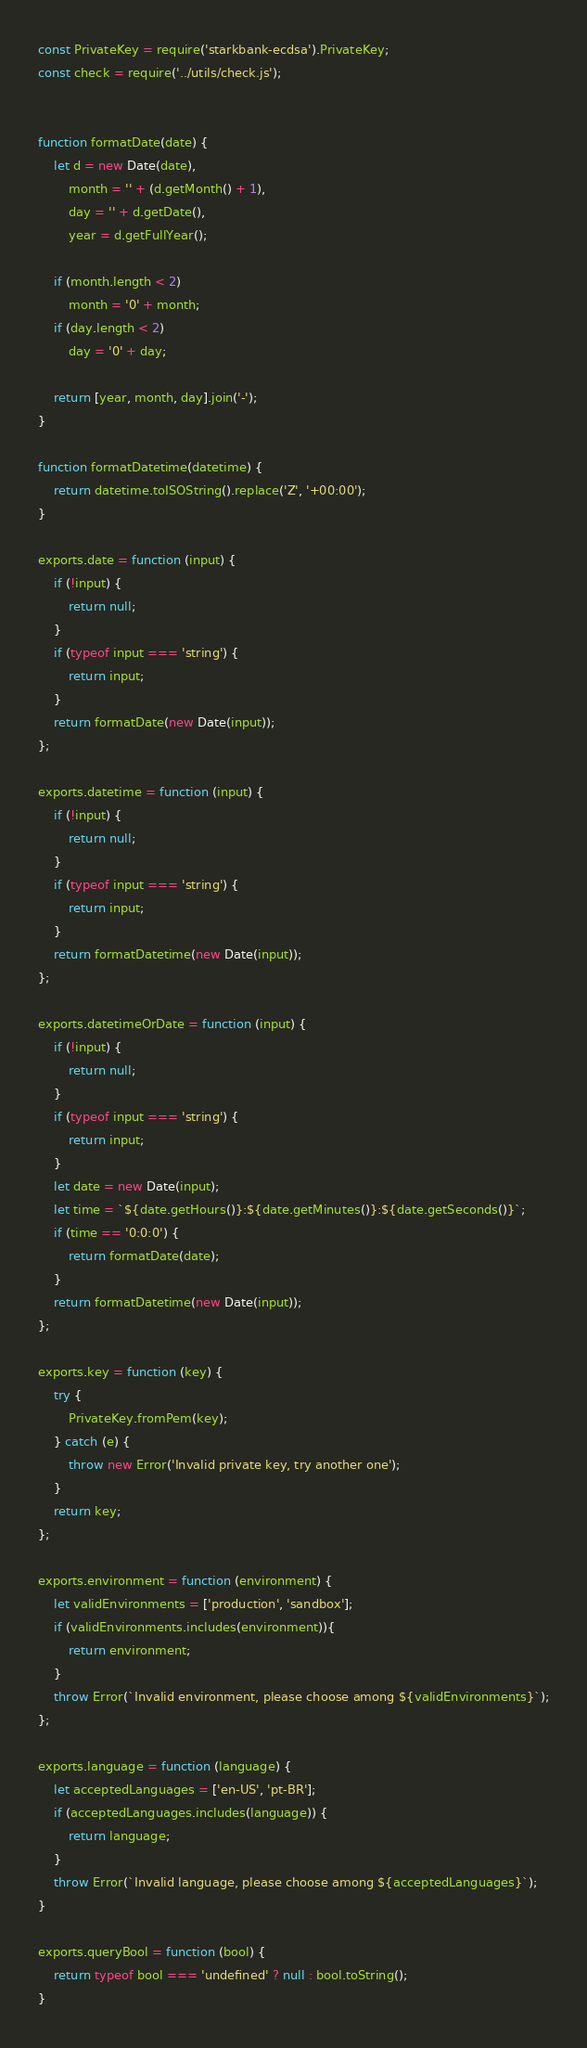Convert code to text. <code><loc_0><loc_0><loc_500><loc_500><_JavaScript_>const PrivateKey = require('starkbank-ecdsa').PrivateKey;
const check = require('../utils/check.js');


function formatDate(date) {
    let d = new Date(date),
        month = '' + (d.getMonth() + 1),
        day = '' + d.getDate(),
        year = d.getFullYear();

    if (month.length < 2)
        month = '0' + month;
    if (day.length < 2)
        day = '0' + day;

    return [year, month, day].join('-');
}

function formatDatetime(datetime) {
    return datetime.toISOString().replace('Z', '+00:00');
}

exports.date = function (input) {
    if (!input) {
        return null;
    }
    if (typeof input === 'string') {
        return input;
    }
    return formatDate(new Date(input));
};

exports.datetime = function (input) {
    if (!input) {
        return null;
    }
    if (typeof input === 'string') {
        return input;
    }
    return formatDatetime(new Date(input));
};

exports.datetimeOrDate = function (input) {
    if (!input) {
        return null;
    }
    if (typeof input === 'string') {
        return input;
    }
    let date = new Date(input);
    let time = `${date.getHours()}:${date.getMinutes()}:${date.getSeconds()}`;
    if (time == '0:0:0') {
        return formatDate(date);
    }
    return formatDatetime(new Date(input));
};

exports.key = function (key) {
    try {
        PrivateKey.fromPem(key);
    } catch (e) {
        throw new Error('Invalid private key, try another one');
    }
    return key;
};

exports.environment = function (environment) {
    let validEnvironments = ['production', 'sandbox'];
    if (validEnvironments.includes(environment)){
        return environment;
    }
    throw Error(`Invalid environment, please choose among ${validEnvironments}`);
};

exports.language = function (language) {
    let acceptedLanguages = ['en-US', 'pt-BR'];
    if (acceptedLanguages.includes(language)) {
        return language;
    }
    throw Error(`Invalid language, please choose among ${acceptedLanguages}`);
}

exports.queryBool = function (bool) {
    return typeof bool === 'undefined' ? null : bool.toString();
}
</code> 